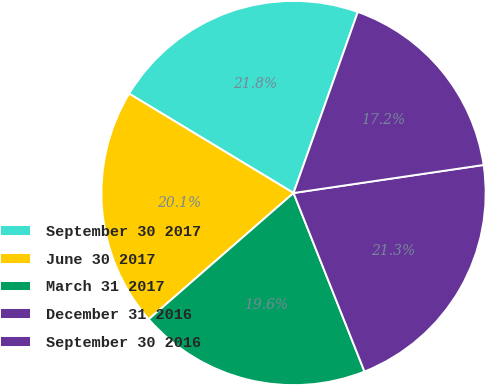Convert chart. <chart><loc_0><loc_0><loc_500><loc_500><pie_chart><fcel>September 30 2017<fcel>June 30 2017<fcel>March 31 2017<fcel>December 31 2016<fcel>September 30 2016<nl><fcel>21.78%<fcel>20.06%<fcel>19.61%<fcel>21.31%<fcel>17.24%<nl></chart> 